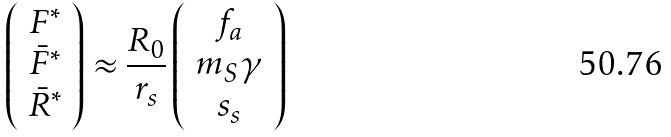<formula> <loc_0><loc_0><loc_500><loc_500>\left ( \begin{array} { c } F ^ { * } \\ \bar { F } ^ { * } \\ \bar { R } ^ { * } \end{array} \right ) \approx \frac { R _ { 0 } } { r _ { s } } \left ( \begin{array} { c } f _ { a } \\ m _ { S } \gamma \\ s _ { s } \end{array} \right )</formula> 